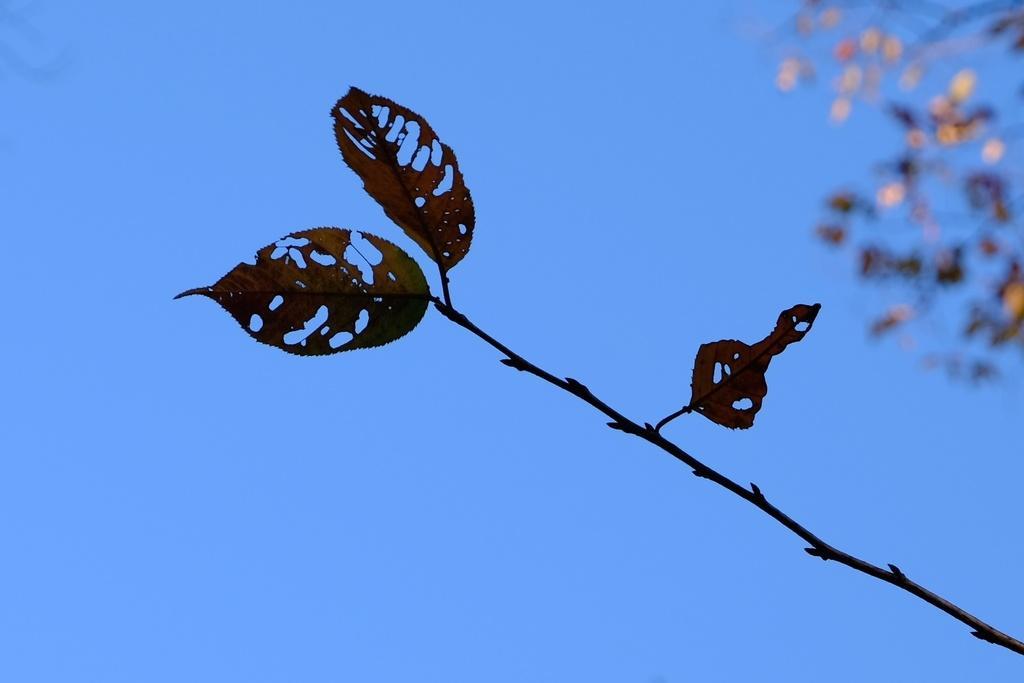Describe this image in one or two sentences. The picture consists of a stem and leaves. The background is blurred. 